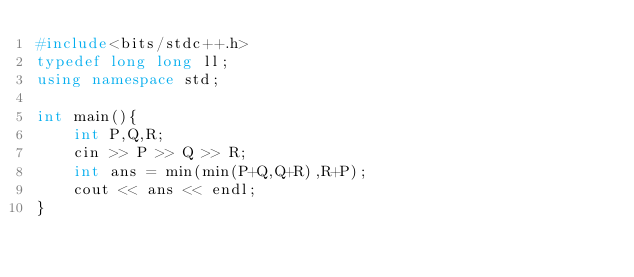Convert code to text. <code><loc_0><loc_0><loc_500><loc_500><_C++_>#include<bits/stdc++.h>
typedef long long ll;
using namespace std;

int main(){
    int P,Q,R;
    cin >> P >> Q >> R;
    int ans = min(min(P+Q,Q+R),R+P);
    cout << ans << endl;
}
</code> 